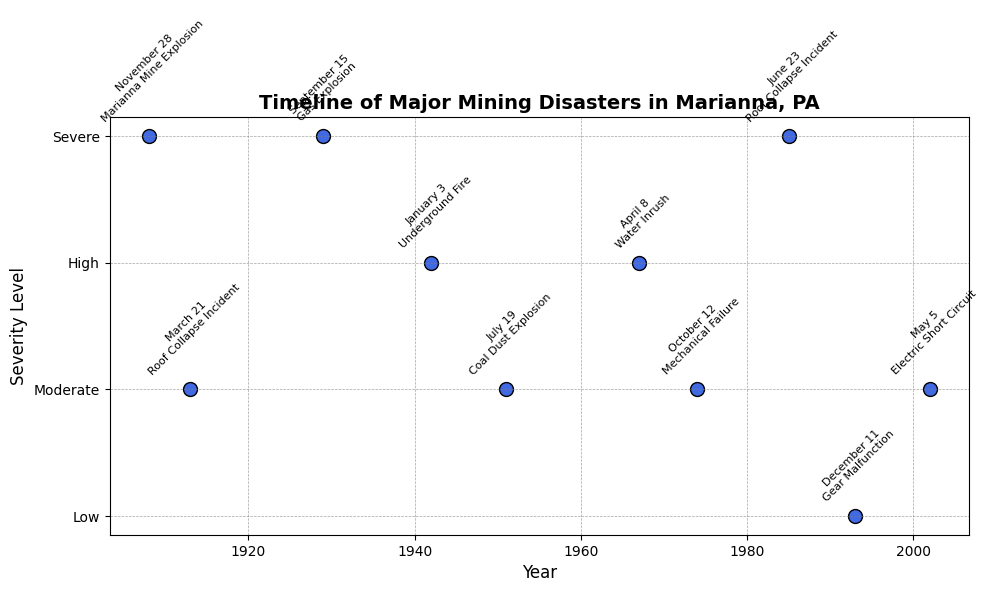What is the most severe disaster that occurred first? Look at the timeline and identify the first occurrence of a "Severe" severity level. The first severe disaster listed is the Marianna Mine Explosion in 1908.
Answer: Marianna Mine Explosion Which year had the highest number of severe mining disasters? Count the number of dots labeled "Severe" for each year. The years with severe disasters are 1908, 1929, and 1985, each having one severe disaster, so they are tied.
Answer: 1908, 1929, 1985 What is the latest event with a "High" severity level? Check the timeline and locate the highest severity level of "High". The latest "High" severity event is the Water Inrush in 1967.
Answer: Water Inrush How many years had exactly one disaster event? Count the number of years on the timeline where only one event is marked. Years with a single event are 1908, 1913, 1929, 1942, 1951, 1967, 1974, and 2002.
Answer: 8 years What is the average severity level of all the disasters in the 20th century? Convert each severity level to its numeric value, sum them, and divide by the number of events in the 20th century (1900-1999). Calculations: (4+2+4+3+2+3+2+4)/8 = 24/8 = 3 (High)
Answer: 3 Which disaster is closest to occurring at the midpoint of the timeline? Identify the years range (1908-2002), midpoint year is (1908+2002)/2 = 1955. Look for the disaster closest to year 1955. Roof Collapse Incident in 1951 is closest.
Answer: Roof Collapse Incident Between the Gas Explosion and the Mechanical Failure, which has higher severity? Compare the severity levels of both events. Gas Explosion has a severity of "Severe" (4) and Mechanical Failure has "Moderate" (2). "Severe" is higher.
Answer: Gas Explosion Which color is used to mark disaster events in the plot? The plot uses scatter points to mark events, the specified color for points is royalblue.
Answer: RoyalBlue What is the severity level of the disaster that occurred in December 1993? Look at the timeline for 1993 and observe the severity level. Gear Malfunction in December 1993 has a "Low" severity level.
Answer: Low How many disasters occurred before 1950? Count all the events on the plot before 1950. The disasters before 1950 are those in years 1908, 1913, 1929, and 1942.
Answer: 4 